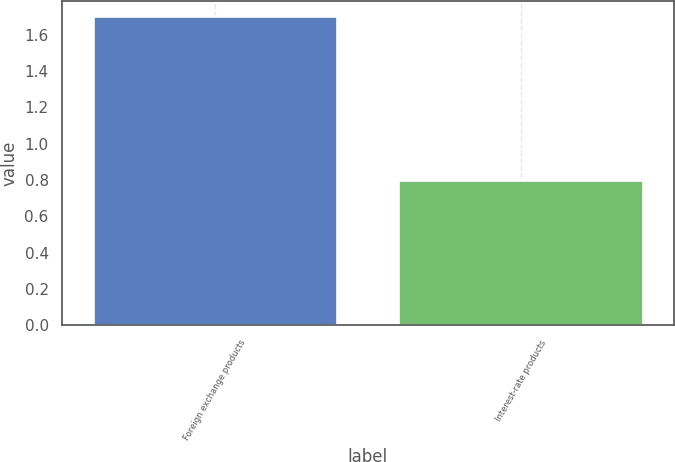Convert chart. <chart><loc_0><loc_0><loc_500><loc_500><bar_chart><fcel>Foreign exchange products<fcel>Interest-rate products<nl><fcel>1.7<fcel>0.8<nl></chart> 